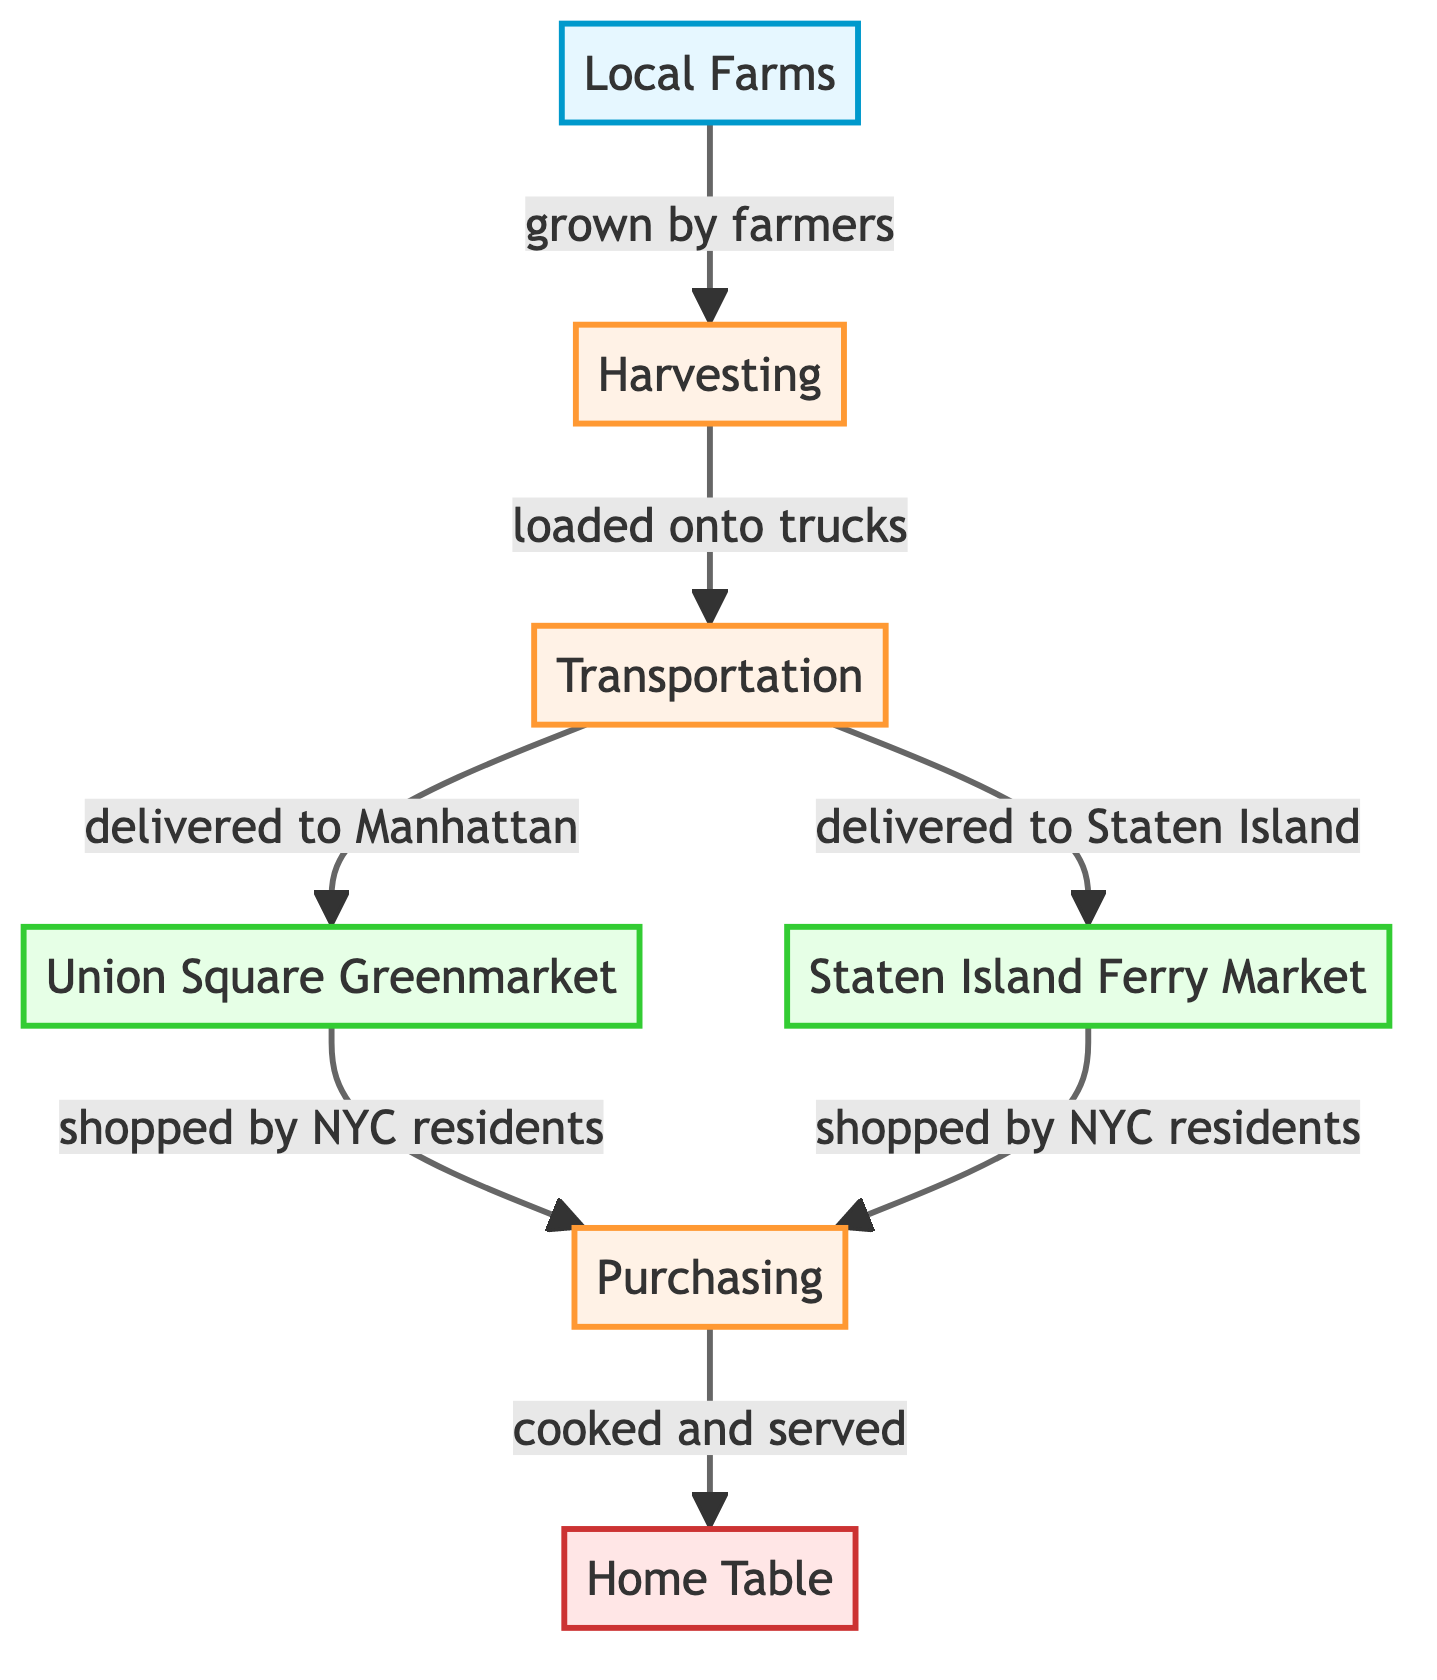What is the first node in the food chain? The first node represents "Local Farms" which is the starting point of the food chain as shown at the top of the diagram.
Answer: Local Farms How many markets are presented in the diagram? By analyzing the diagram, there are two market nodes: "Union Square Greenmarket" and "Staten Island Ferry Market."
Answer: 2 What process follows "Transportation"? The diagram shows that after "Transportation," the next step is "Union Square Greenmarket" or "Staten Island Ferry Market," indicating that the food is delivered to these markets before being purchased.
Answer: Union Square Greenmarket or Staten Island Ferry Market Which process is associated with the final consumer? The final consumer processes "Home Table," indicating that after purchasing food, it is cooked and served at home.
Answer: Home Table What do NYC residents do at the market nodes? The diagram illustrates that at both market nodes, NYC residents engage in purchasing the food items that have been transported.
Answer: Purchasing What is the connection between "Harvesting" and "Transportation"? The connection indicates that after "Harvesting," the food is loaded onto trucks, which leads to the next process of "Transportation" to the markets.
Answer: Loaded onto trucks What is delivered to Manhattan according to the diagram? The diagram specifically states that food is delivered to the "Union Square Greenmarket" in Manhattan, which is one of the market destinations for the products.
Answer: Union Square Greenmarket What is the role of farmers in the food chain? Farmers are responsible for the initial growth of the produce as indicated in the connection between "Local Farms" and "Harvesting."
Answer: Grown by farmers 